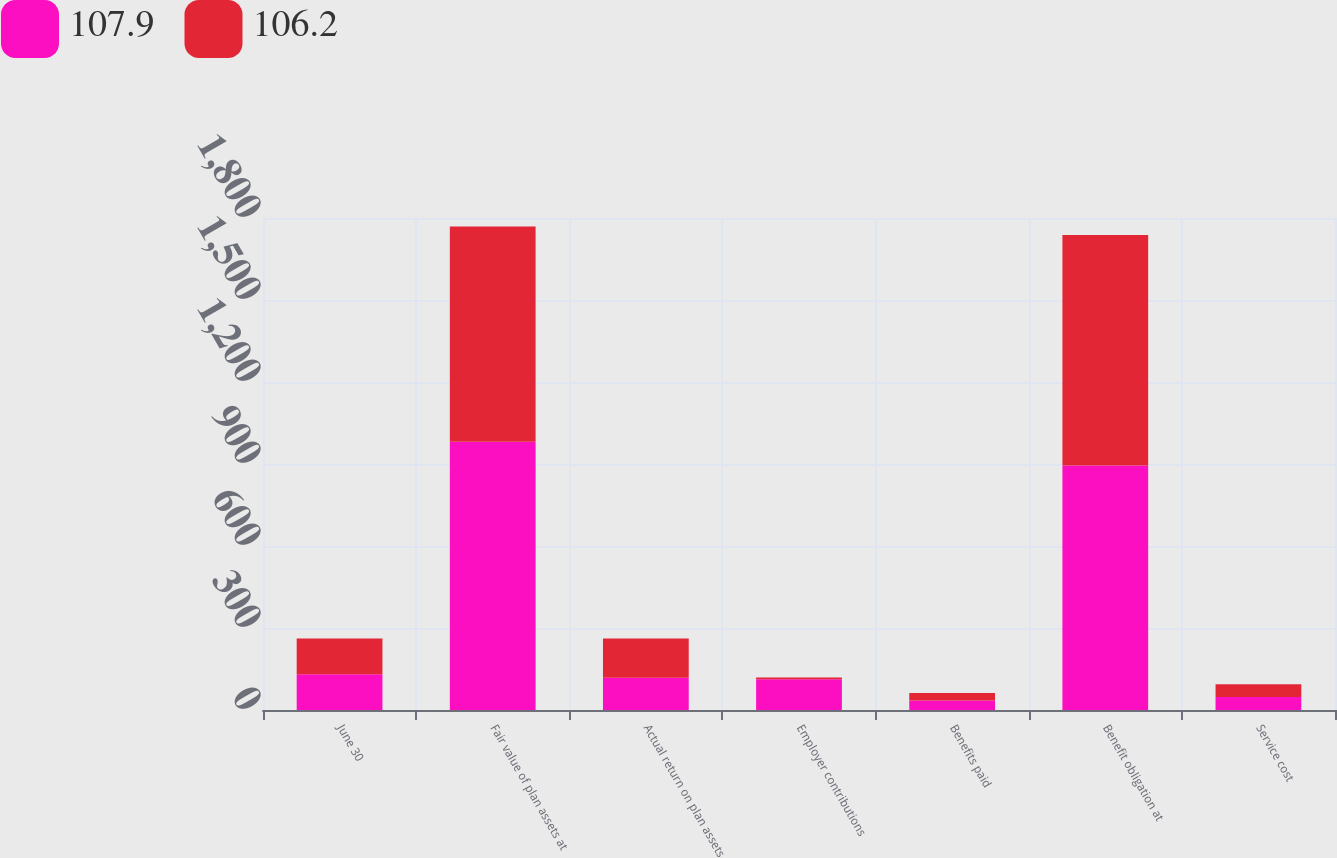<chart> <loc_0><loc_0><loc_500><loc_500><stacked_bar_chart><ecel><fcel>June 30<fcel>Fair value of plan assets at<fcel>Actual return on plan assets<fcel>Employer contributions<fcel>Benefits paid<fcel>Benefit obligation at<fcel>Service cost<nl><fcel>107.9<fcel>130.95<fcel>981.7<fcel>117.6<fcel>112.3<fcel>35.2<fcel>894.9<fcel>47.6<nl><fcel>106.2<fcel>130.95<fcel>787<fcel>144.3<fcel>6.3<fcel>27.2<fcel>842.8<fcel>46.2<nl></chart> 